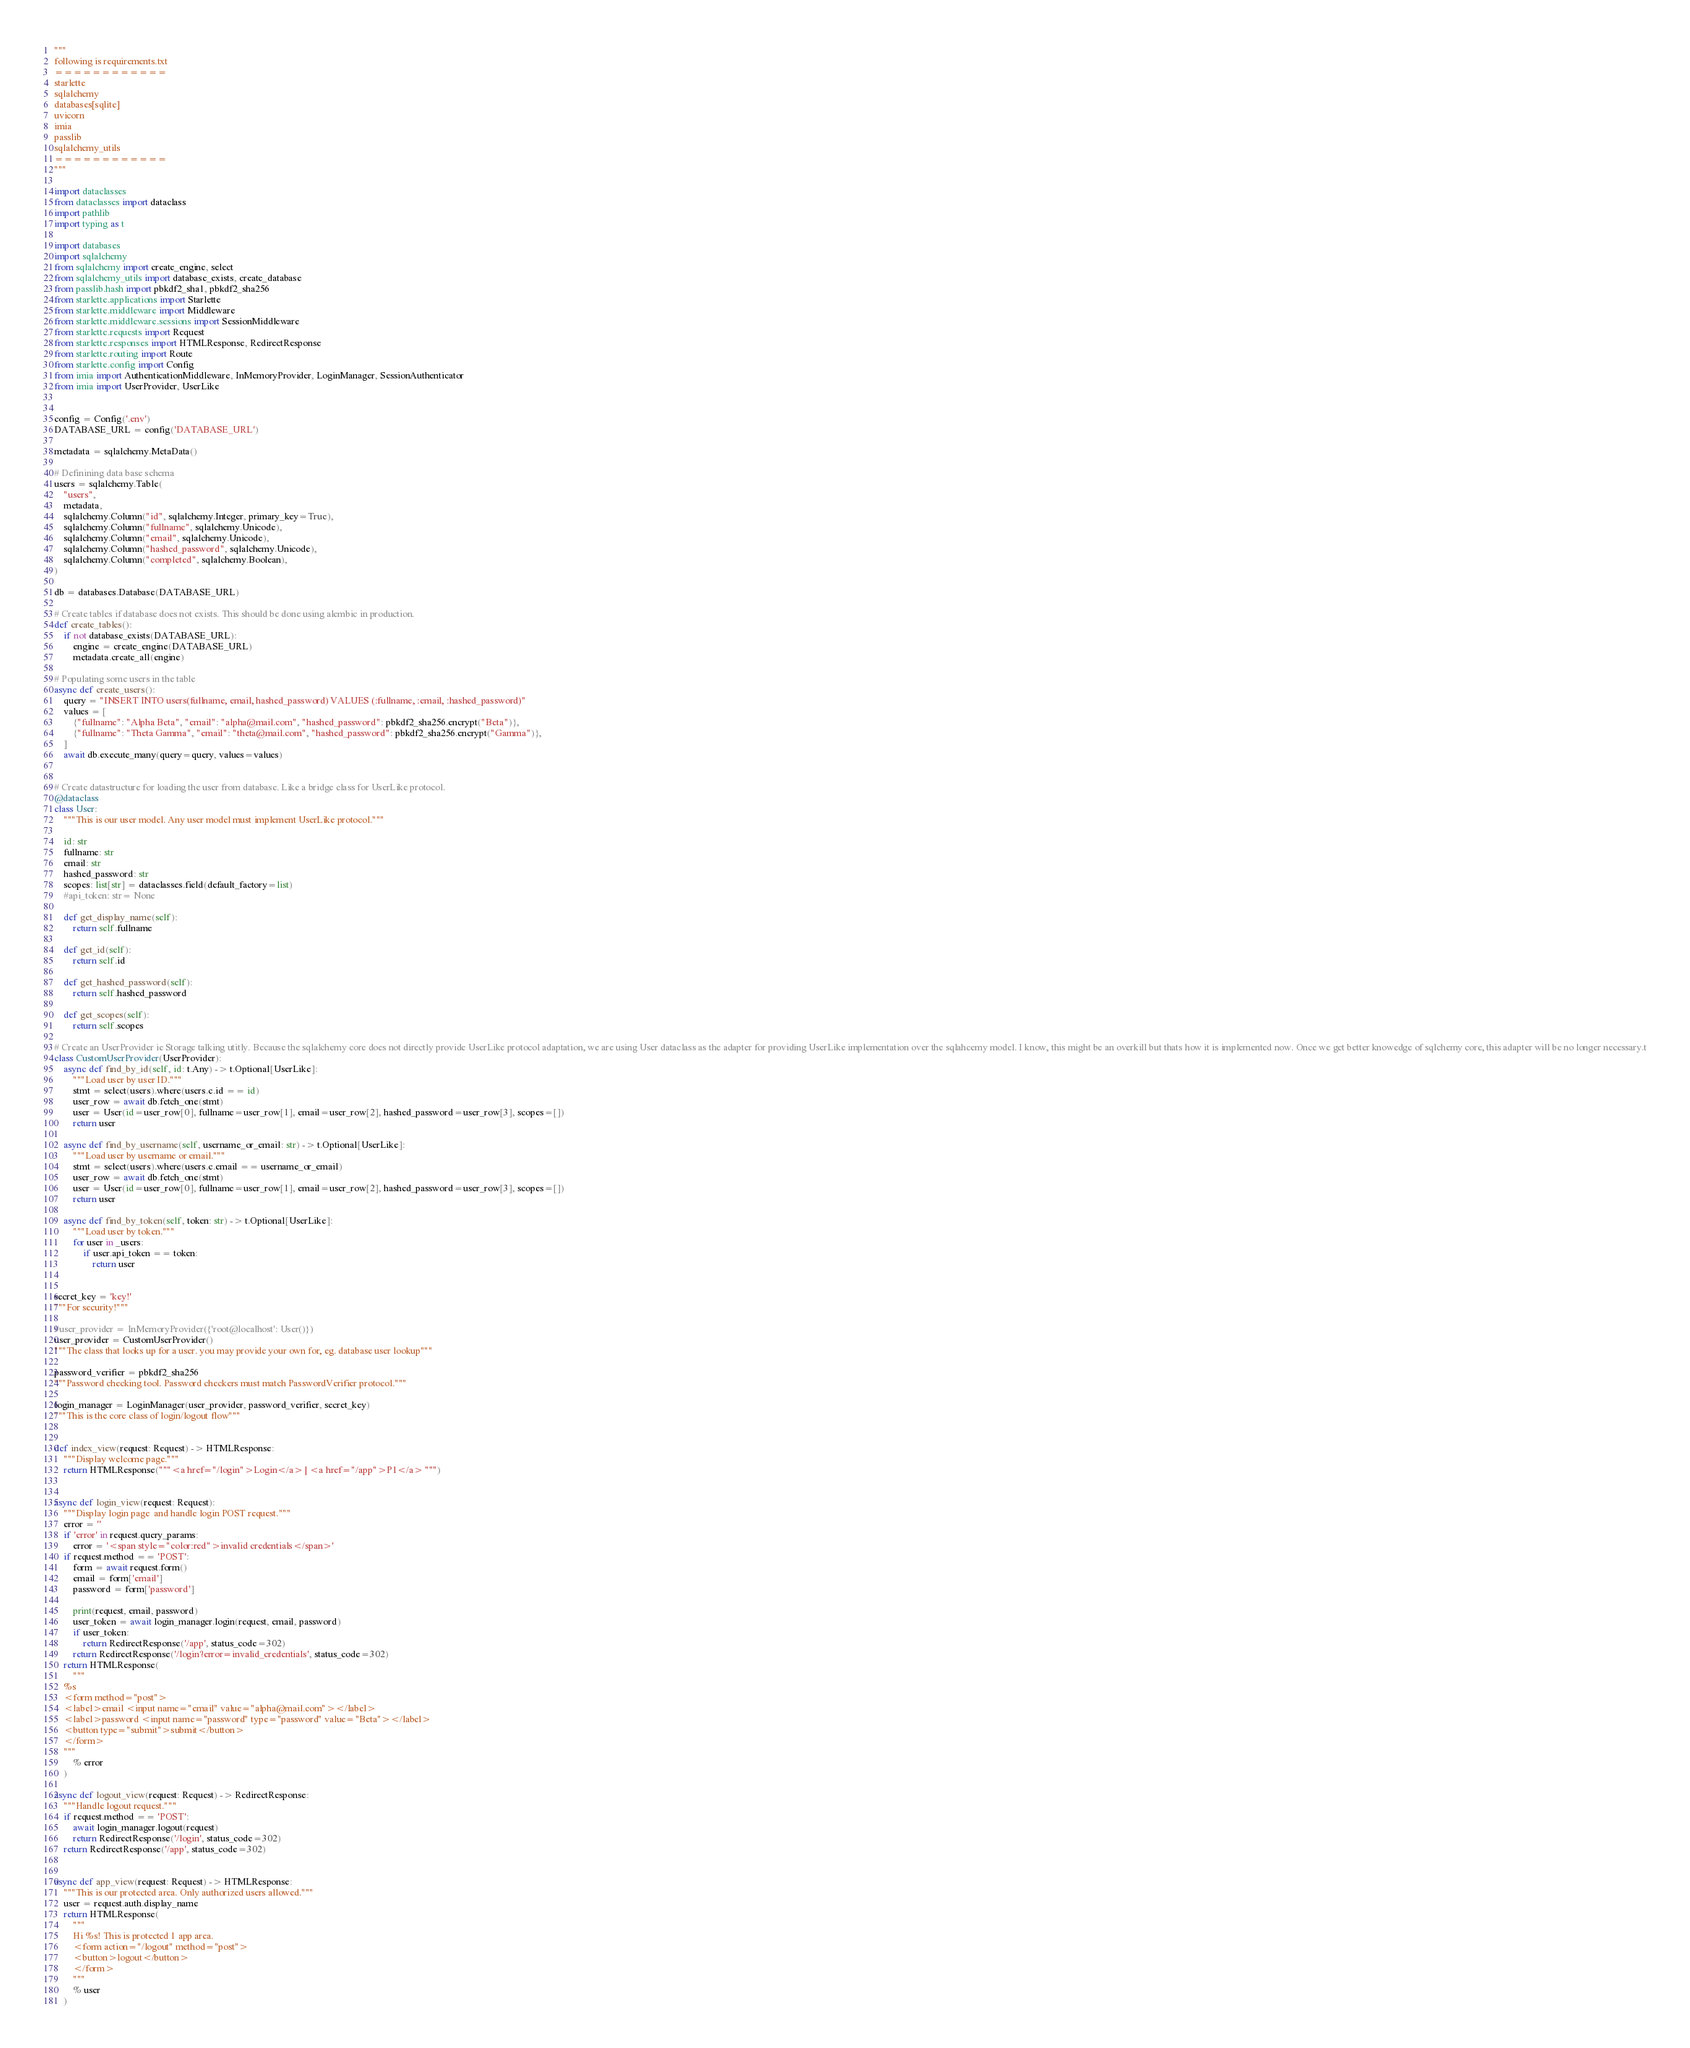<code> <loc_0><loc_0><loc_500><loc_500><_Python_>"""
following is requirements.txt
============
starlette
sqlalchemy
databases[sqlite]
uvicorn
imia
passlib
sqlalchemy_utils
============
"""

import dataclasses
from dataclasses import dataclass
import pathlib
import typing as t

import databases
import sqlalchemy
from sqlalchemy import create_engine, select
from sqlalchemy_utils import database_exists, create_database
from passlib.hash import pbkdf2_sha1, pbkdf2_sha256
from starlette.applications import Starlette
from starlette.middleware import Middleware
from starlette.middleware.sessions import SessionMiddleware
from starlette.requests import Request
from starlette.responses import HTMLResponse, RedirectResponse
from starlette.routing import Route
from starlette.config import Config
from imia import AuthenticationMiddleware, InMemoryProvider, LoginManager, SessionAuthenticator
from imia import UserProvider, UserLike


config = Config('.env')
DATABASE_URL = config('DATABASE_URL')

metadata = sqlalchemy.MetaData()

# Definining data base schema
users = sqlalchemy.Table(
    "users",
    metadata,
    sqlalchemy.Column("id", sqlalchemy.Integer, primary_key=True),
    sqlalchemy.Column("fullname", sqlalchemy.Unicode),
    sqlalchemy.Column("email", sqlalchemy.Unicode),
    sqlalchemy.Column("hashed_password", sqlalchemy.Unicode),
    sqlalchemy.Column("completed", sqlalchemy.Boolean),
)

db = databases.Database(DATABASE_URL)

# Create tables if database does not exists. This should be done using alembic in production.
def create_tables():
    if not database_exists(DATABASE_URL):
        engine = create_engine(DATABASE_URL)
        metadata.create_all(engine)

# Populating some users in the table
async def create_users():
    query = "INSERT INTO users(fullname, email, hashed_password) VALUES (:fullname, :email, :hashed_password)"
    values = [
        {"fullname": "Alpha Beta", "email": "alpha@mail.com", "hashed_password": pbkdf2_sha256.encrypt("Beta")},
        {"fullname": "Theta Gamma", "email": "theta@mail.com", "hashed_password": pbkdf2_sha256.encrypt("Gamma")},
    ]
    await db.execute_many(query=query, values=values)


# Create datastructure for loading the user from database. Like a bridge class for UserLike protocol.
@dataclass
class User:
    """This is our user model. Any user model must implement UserLike protocol."""

    id: str
    fullname: str
    email: str
    hashed_password: str
    scopes: list[str] = dataclasses.field(default_factory=list)
    #api_token: str= None

    def get_display_name(self):
        return self.fullname

    def get_id(self):
        return self.id

    def get_hashed_password(self):
        return self.hashed_password

    def get_scopes(self):
        return self.scopes

# Create an UserProvider ie Storage talking utitly. Because the sqlalchemy core does not directly provide UserLike protocol adaptation, we are using User dataclass as the adapter for providing UserLike implementation over the sqlahcemy model. I know, this might be an overkill but thats how it is implemented now. Once we get better knowedge of sqlchemy core, this adapter will be no longer necessary.t
class CustomUserProvider(UserProvider):
    async def find_by_id(self, id: t.Any) -> t.Optional[UserLike]:
        """Load user by user ID."""
        stmt = select(users).where(users.c.id == id)
        user_row = await db.fetch_one(stmt)
        user = User(id=user_row[0], fullname=user_row[1], email=user_row[2], hashed_password=user_row[3], scopes=[])
        return user

    async def find_by_username(self, username_or_email: str) -> t.Optional[UserLike]:
        """Load user by username or email."""
        stmt = select(users).where(users.c.email == username_or_email)
        user_row = await db.fetch_one(stmt)
        user = User(id=user_row[0], fullname=user_row[1], email=user_row[2], hashed_password=user_row[3], scopes=[])
        return user

    async def find_by_token(self, token: str) -> t.Optional[UserLike]:
        """Load user by token."""
        for user in _users:
            if user.api_token == token:
                return user


secret_key = 'key!'
"""For security!"""

#user_provider = InMemoryProvider({'root@localhost': User()})
user_provider = CustomUserProvider()
"""The class that looks up for a user. you may provide your own for, eg. database user lookup"""

password_verifier = pbkdf2_sha256
"""Password checking tool. Password checkers must match PasswordVerifier protocol."""

login_manager = LoginManager(user_provider, password_verifier, secret_key)
"""This is the core class of login/logout flow"""


def index_view(request: Request) -> HTMLResponse:
    """Display welcome page."""
    return HTMLResponse("""<a href="/login">Login</a> | <a href="/app">P1</a> """)


async def login_view(request: Request):
    """Display login page  and handle login POST request."""
    error = ''
    if 'error' in request.query_params:
        error = '<span style="color:red">invalid credentials</span>'
    if request.method == 'POST':
        form = await request.form()
        email = form['email']
        password = form['password']

        print(request, email, password)
        user_token = await login_manager.login(request, email, password)
        if user_token:
            return RedirectResponse('/app', status_code=302)
        return RedirectResponse('/login?error=invalid_credentials', status_code=302)
    return HTMLResponse(
        """
    %s
    <form method="post">
    <label>email <input name="email" value="alpha@mail.com"></label>
    <label>password <input name="password" type="password" value="Beta"></label>
    <button type="submit">submit</button>
    </form>
    """
        % error
    )

async def logout_view(request: Request) -> RedirectResponse:
    """Handle logout request."""
    if request.method == 'POST':
        await login_manager.logout(request)
        return RedirectResponse('/login', status_code=302)
    return RedirectResponse('/app', status_code=302)


async def app_view(request: Request) -> HTMLResponse:
    """This is our protected area. Only authorized users allowed."""
    user = request.auth.display_name
    return HTMLResponse(
        """
        Hi %s! This is protected 1 app area.
        <form action="/logout" method="post">
        <button>logout</button>
        </form>
        """
        % user
    )

</code> 